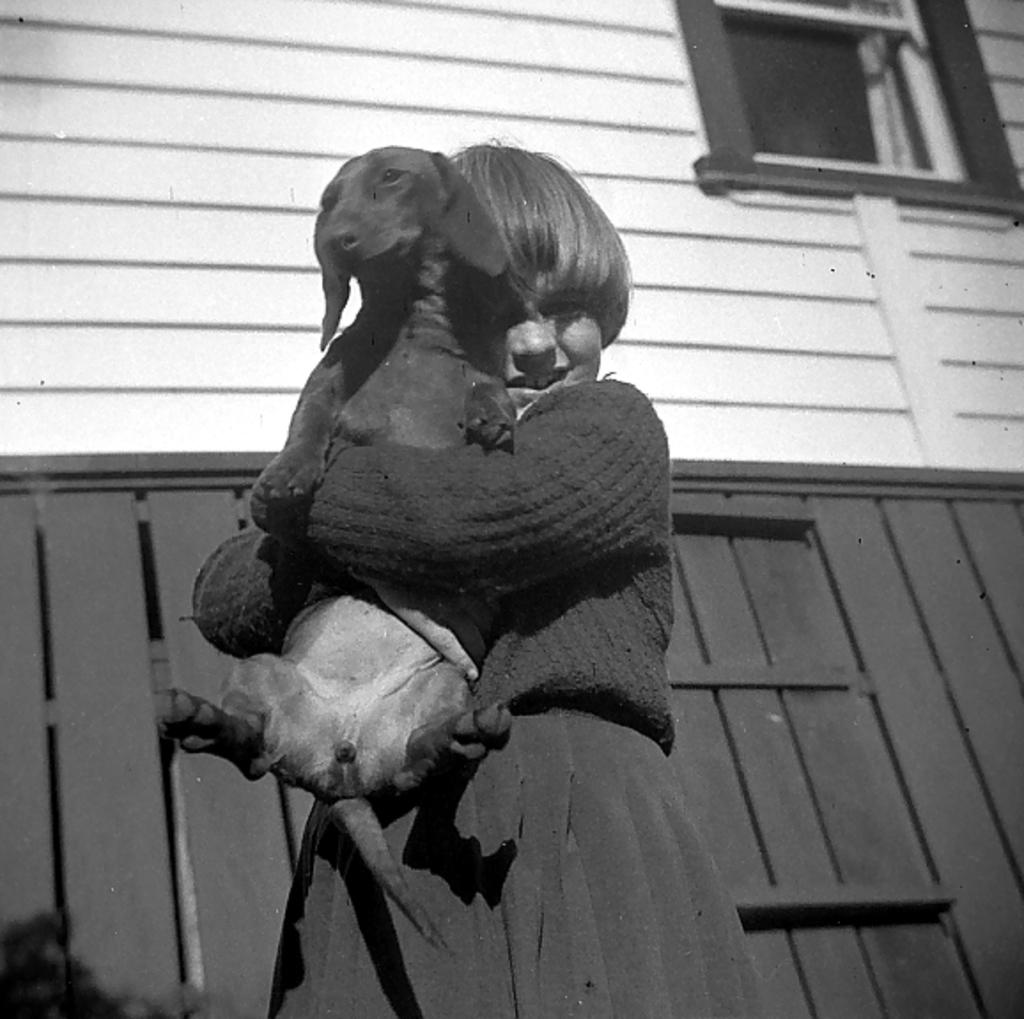Who is the main subject in the image? There is a girl in the image. What is the girl holding in the image? The girl is holding a dog. How is the girl dressed in the image? The girl is wearing a sweater and skirt. What can be observed about the background of the image? The background of the image is dark. How much salt is visible on the ground in the image? There is no salt visible on the ground in the image, as it does not contain any outdoor or snowy scenes. What type of car can be seen in the background of the image? There is no car present in the image; it features a girl holding a dog with a dark background. 